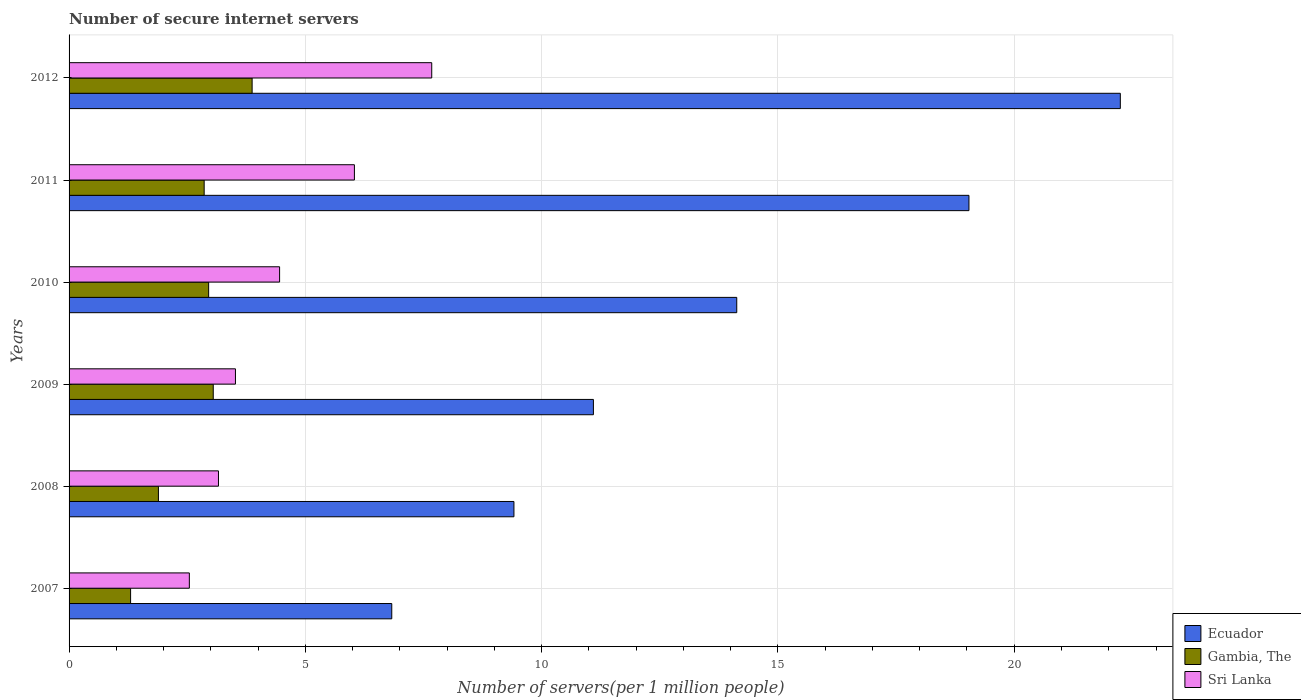How many groups of bars are there?
Your answer should be very brief. 6. Are the number of bars per tick equal to the number of legend labels?
Your answer should be compact. Yes. How many bars are there on the 2nd tick from the top?
Make the answer very short. 3. How many bars are there on the 4th tick from the bottom?
Your answer should be very brief. 3. What is the label of the 1st group of bars from the top?
Offer a very short reply. 2012. In how many cases, is the number of bars for a given year not equal to the number of legend labels?
Make the answer very short. 0. What is the number of secure internet servers in Ecuador in 2008?
Ensure brevity in your answer.  9.41. Across all years, what is the maximum number of secure internet servers in Ecuador?
Keep it short and to the point. 22.24. Across all years, what is the minimum number of secure internet servers in Ecuador?
Make the answer very short. 6.83. In which year was the number of secure internet servers in Ecuador minimum?
Provide a succinct answer. 2007. What is the total number of secure internet servers in Sri Lanka in the graph?
Offer a terse response. 27.39. What is the difference between the number of secure internet servers in Gambia, The in 2009 and that in 2011?
Offer a terse response. 0.19. What is the difference between the number of secure internet servers in Ecuador in 2010 and the number of secure internet servers in Sri Lanka in 2012?
Ensure brevity in your answer.  6.45. What is the average number of secure internet servers in Gambia, The per year?
Offer a terse response. 2.65. In the year 2011, what is the difference between the number of secure internet servers in Ecuador and number of secure internet servers in Gambia, The?
Your answer should be compact. 16.18. What is the ratio of the number of secure internet servers in Gambia, The in 2008 to that in 2011?
Provide a succinct answer. 0.66. Is the difference between the number of secure internet servers in Ecuador in 2007 and 2010 greater than the difference between the number of secure internet servers in Gambia, The in 2007 and 2010?
Your answer should be very brief. No. What is the difference between the highest and the second highest number of secure internet servers in Gambia, The?
Make the answer very short. 0.82. What is the difference between the highest and the lowest number of secure internet servers in Sri Lanka?
Keep it short and to the point. 5.13. In how many years, is the number of secure internet servers in Sri Lanka greater than the average number of secure internet servers in Sri Lanka taken over all years?
Ensure brevity in your answer.  2. Is the sum of the number of secure internet servers in Gambia, The in 2010 and 2012 greater than the maximum number of secure internet servers in Sri Lanka across all years?
Provide a short and direct response. No. What does the 3rd bar from the top in 2010 represents?
Offer a very short reply. Ecuador. What does the 2nd bar from the bottom in 2008 represents?
Provide a succinct answer. Gambia, The. Is it the case that in every year, the sum of the number of secure internet servers in Gambia, The and number of secure internet servers in Ecuador is greater than the number of secure internet servers in Sri Lanka?
Provide a succinct answer. Yes. Are the values on the major ticks of X-axis written in scientific E-notation?
Provide a short and direct response. No. Does the graph contain any zero values?
Keep it short and to the point. No. Does the graph contain grids?
Your answer should be compact. Yes. How are the legend labels stacked?
Provide a succinct answer. Vertical. What is the title of the graph?
Your response must be concise. Number of secure internet servers. Does "Benin" appear as one of the legend labels in the graph?
Keep it short and to the point. No. What is the label or title of the X-axis?
Give a very brief answer. Number of servers(per 1 million people). What is the Number of servers(per 1 million people) of Ecuador in 2007?
Keep it short and to the point. 6.83. What is the Number of servers(per 1 million people) of Gambia, The in 2007?
Offer a terse response. 1.3. What is the Number of servers(per 1 million people) in Sri Lanka in 2007?
Offer a terse response. 2.55. What is the Number of servers(per 1 million people) in Ecuador in 2008?
Provide a succinct answer. 9.41. What is the Number of servers(per 1 million people) in Gambia, The in 2008?
Offer a very short reply. 1.89. What is the Number of servers(per 1 million people) in Sri Lanka in 2008?
Keep it short and to the point. 3.16. What is the Number of servers(per 1 million people) of Ecuador in 2009?
Provide a succinct answer. 11.09. What is the Number of servers(per 1 million people) of Gambia, The in 2009?
Your answer should be compact. 3.05. What is the Number of servers(per 1 million people) of Sri Lanka in 2009?
Ensure brevity in your answer.  3.52. What is the Number of servers(per 1 million people) of Ecuador in 2010?
Make the answer very short. 14.13. What is the Number of servers(per 1 million people) of Gambia, The in 2010?
Provide a succinct answer. 2.95. What is the Number of servers(per 1 million people) of Sri Lanka in 2010?
Provide a succinct answer. 4.45. What is the Number of servers(per 1 million people) of Ecuador in 2011?
Your answer should be very brief. 19.04. What is the Number of servers(per 1 million people) in Gambia, The in 2011?
Keep it short and to the point. 2.86. What is the Number of servers(per 1 million people) of Sri Lanka in 2011?
Provide a short and direct response. 6.04. What is the Number of servers(per 1 million people) in Ecuador in 2012?
Offer a terse response. 22.24. What is the Number of servers(per 1 million people) in Gambia, The in 2012?
Your answer should be very brief. 3.87. What is the Number of servers(per 1 million people) in Sri Lanka in 2012?
Your response must be concise. 7.67. Across all years, what is the maximum Number of servers(per 1 million people) in Ecuador?
Make the answer very short. 22.24. Across all years, what is the maximum Number of servers(per 1 million people) of Gambia, The?
Make the answer very short. 3.87. Across all years, what is the maximum Number of servers(per 1 million people) in Sri Lanka?
Ensure brevity in your answer.  7.67. Across all years, what is the minimum Number of servers(per 1 million people) in Ecuador?
Your response must be concise. 6.83. Across all years, what is the minimum Number of servers(per 1 million people) of Gambia, The?
Offer a terse response. 1.3. Across all years, what is the minimum Number of servers(per 1 million people) of Sri Lanka?
Your answer should be very brief. 2.55. What is the total Number of servers(per 1 million people) of Ecuador in the graph?
Make the answer very short. 82.75. What is the total Number of servers(per 1 million people) of Gambia, The in the graph?
Provide a short and direct response. 15.93. What is the total Number of servers(per 1 million people) of Sri Lanka in the graph?
Offer a terse response. 27.39. What is the difference between the Number of servers(per 1 million people) of Ecuador in 2007 and that in 2008?
Offer a terse response. -2.58. What is the difference between the Number of servers(per 1 million people) in Gambia, The in 2007 and that in 2008?
Make the answer very short. -0.59. What is the difference between the Number of servers(per 1 million people) of Sri Lanka in 2007 and that in 2008?
Provide a short and direct response. -0.62. What is the difference between the Number of servers(per 1 million people) of Ecuador in 2007 and that in 2009?
Keep it short and to the point. -4.27. What is the difference between the Number of servers(per 1 million people) in Gambia, The in 2007 and that in 2009?
Provide a succinct answer. -1.75. What is the difference between the Number of servers(per 1 million people) in Sri Lanka in 2007 and that in 2009?
Give a very brief answer. -0.98. What is the difference between the Number of servers(per 1 million people) of Ecuador in 2007 and that in 2010?
Offer a very short reply. -7.3. What is the difference between the Number of servers(per 1 million people) in Gambia, The in 2007 and that in 2010?
Provide a short and direct response. -1.65. What is the difference between the Number of servers(per 1 million people) of Sri Lanka in 2007 and that in 2010?
Offer a terse response. -1.91. What is the difference between the Number of servers(per 1 million people) of Ecuador in 2007 and that in 2011?
Make the answer very short. -12.21. What is the difference between the Number of servers(per 1 million people) in Gambia, The in 2007 and that in 2011?
Ensure brevity in your answer.  -1.56. What is the difference between the Number of servers(per 1 million people) of Sri Lanka in 2007 and that in 2011?
Your answer should be compact. -3.49. What is the difference between the Number of servers(per 1 million people) of Ecuador in 2007 and that in 2012?
Offer a terse response. -15.42. What is the difference between the Number of servers(per 1 million people) of Gambia, The in 2007 and that in 2012?
Offer a very short reply. -2.57. What is the difference between the Number of servers(per 1 million people) in Sri Lanka in 2007 and that in 2012?
Ensure brevity in your answer.  -5.13. What is the difference between the Number of servers(per 1 million people) of Ecuador in 2008 and that in 2009?
Offer a terse response. -1.68. What is the difference between the Number of servers(per 1 million people) of Gambia, The in 2008 and that in 2009?
Make the answer very short. -1.16. What is the difference between the Number of servers(per 1 million people) in Sri Lanka in 2008 and that in 2009?
Offer a very short reply. -0.36. What is the difference between the Number of servers(per 1 million people) in Ecuador in 2008 and that in 2010?
Keep it short and to the point. -4.71. What is the difference between the Number of servers(per 1 million people) of Gambia, The in 2008 and that in 2010?
Offer a very short reply. -1.06. What is the difference between the Number of servers(per 1 million people) in Sri Lanka in 2008 and that in 2010?
Your answer should be very brief. -1.29. What is the difference between the Number of servers(per 1 million people) of Ecuador in 2008 and that in 2011?
Your answer should be compact. -9.63. What is the difference between the Number of servers(per 1 million people) of Gambia, The in 2008 and that in 2011?
Make the answer very short. -0.97. What is the difference between the Number of servers(per 1 million people) in Sri Lanka in 2008 and that in 2011?
Your answer should be compact. -2.88. What is the difference between the Number of servers(per 1 million people) of Ecuador in 2008 and that in 2012?
Offer a very short reply. -12.83. What is the difference between the Number of servers(per 1 million people) in Gambia, The in 2008 and that in 2012?
Keep it short and to the point. -1.98. What is the difference between the Number of servers(per 1 million people) of Sri Lanka in 2008 and that in 2012?
Provide a succinct answer. -4.51. What is the difference between the Number of servers(per 1 million people) in Ecuador in 2009 and that in 2010?
Your response must be concise. -3.03. What is the difference between the Number of servers(per 1 million people) in Gambia, The in 2009 and that in 2010?
Your answer should be very brief. 0.1. What is the difference between the Number of servers(per 1 million people) in Sri Lanka in 2009 and that in 2010?
Give a very brief answer. -0.93. What is the difference between the Number of servers(per 1 million people) of Ecuador in 2009 and that in 2011?
Offer a terse response. -7.95. What is the difference between the Number of servers(per 1 million people) in Gambia, The in 2009 and that in 2011?
Your response must be concise. 0.19. What is the difference between the Number of servers(per 1 million people) of Sri Lanka in 2009 and that in 2011?
Provide a succinct answer. -2.52. What is the difference between the Number of servers(per 1 million people) in Ecuador in 2009 and that in 2012?
Provide a short and direct response. -11.15. What is the difference between the Number of servers(per 1 million people) in Gambia, The in 2009 and that in 2012?
Ensure brevity in your answer.  -0.82. What is the difference between the Number of servers(per 1 million people) in Sri Lanka in 2009 and that in 2012?
Make the answer very short. -4.15. What is the difference between the Number of servers(per 1 million people) of Ecuador in 2010 and that in 2011?
Keep it short and to the point. -4.91. What is the difference between the Number of servers(per 1 million people) in Gambia, The in 2010 and that in 2011?
Your answer should be compact. 0.09. What is the difference between the Number of servers(per 1 million people) in Sri Lanka in 2010 and that in 2011?
Make the answer very short. -1.58. What is the difference between the Number of servers(per 1 million people) of Ecuador in 2010 and that in 2012?
Your response must be concise. -8.12. What is the difference between the Number of servers(per 1 million people) of Gambia, The in 2010 and that in 2012?
Offer a very short reply. -0.92. What is the difference between the Number of servers(per 1 million people) in Sri Lanka in 2010 and that in 2012?
Ensure brevity in your answer.  -3.22. What is the difference between the Number of servers(per 1 million people) in Ecuador in 2011 and that in 2012?
Offer a terse response. -3.2. What is the difference between the Number of servers(per 1 million people) of Gambia, The in 2011 and that in 2012?
Ensure brevity in your answer.  -1.01. What is the difference between the Number of servers(per 1 million people) in Sri Lanka in 2011 and that in 2012?
Your response must be concise. -1.64. What is the difference between the Number of servers(per 1 million people) in Ecuador in 2007 and the Number of servers(per 1 million people) in Gambia, The in 2008?
Your answer should be very brief. 4.94. What is the difference between the Number of servers(per 1 million people) in Ecuador in 2007 and the Number of servers(per 1 million people) in Sri Lanka in 2008?
Your answer should be compact. 3.67. What is the difference between the Number of servers(per 1 million people) of Gambia, The in 2007 and the Number of servers(per 1 million people) of Sri Lanka in 2008?
Keep it short and to the point. -1.86. What is the difference between the Number of servers(per 1 million people) in Ecuador in 2007 and the Number of servers(per 1 million people) in Gambia, The in 2009?
Ensure brevity in your answer.  3.78. What is the difference between the Number of servers(per 1 million people) in Ecuador in 2007 and the Number of servers(per 1 million people) in Sri Lanka in 2009?
Ensure brevity in your answer.  3.31. What is the difference between the Number of servers(per 1 million people) of Gambia, The in 2007 and the Number of servers(per 1 million people) of Sri Lanka in 2009?
Your response must be concise. -2.22. What is the difference between the Number of servers(per 1 million people) in Ecuador in 2007 and the Number of servers(per 1 million people) in Gambia, The in 2010?
Your answer should be compact. 3.88. What is the difference between the Number of servers(per 1 million people) of Ecuador in 2007 and the Number of servers(per 1 million people) of Sri Lanka in 2010?
Offer a terse response. 2.37. What is the difference between the Number of servers(per 1 million people) in Gambia, The in 2007 and the Number of servers(per 1 million people) in Sri Lanka in 2010?
Keep it short and to the point. -3.15. What is the difference between the Number of servers(per 1 million people) of Ecuador in 2007 and the Number of servers(per 1 million people) of Gambia, The in 2011?
Ensure brevity in your answer.  3.97. What is the difference between the Number of servers(per 1 million people) in Ecuador in 2007 and the Number of servers(per 1 million people) in Sri Lanka in 2011?
Give a very brief answer. 0.79. What is the difference between the Number of servers(per 1 million people) in Gambia, The in 2007 and the Number of servers(per 1 million people) in Sri Lanka in 2011?
Keep it short and to the point. -4.74. What is the difference between the Number of servers(per 1 million people) in Ecuador in 2007 and the Number of servers(per 1 million people) in Gambia, The in 2012?
Make the answer very short. 2.95. What is the difference between the Number of servers(per 1 million people) of Ecuador in 2007 and the Number of servers(per 1 million people) of Sri Lanka in 2012?
Make the answer very short. -0.85. What is the difference between the Number of servers(per 1 million people) in Gambia, The in 2007 and the Number of servers(per 1 million people) in Sri Lanka in 2012?
Provide a short and direct response. -6.37. What is the difference between the Number of servers(per 1 million people) in Ecuador in 2008 and the Number of servers(per 1 million people) in Gambia, The in 2009?
Your response must be concise. 6.36. What is the difference between the Number of servers(per 1 million people) in Ecuador in 2008 and the Number of servers(per 1 million people) in Sri Lanka in 2009?
Ensure brevity in your answer.  5.89. What is the difference between the Number of servers(per 1 million people) in Gambia, The in 2008 and the Number of servers(per 1 million people) in Sri Lanka in 2009?
Your response must be concise. -1.63. What is the difference between the Number of servers(per 1 million people) in Ecuador in 2008 and the Number of servers(per 1 million people) in Gambia, The in 2010?
Your answer should be very brief. 6.46. What is the difference between the Number of servers(per 1 million people) in Ecuador in 2008 and the Number of servers(per 1 million people) in Sri Lanka in 2010?
Your answer should be compact. 4.96. What is the difference between the Number of servers(per 1 million people) in Gambia, The in 2008 and the Number of servers(per 1 million people) in Sri Lanka in 2010?
Ensure brevity in your answer.  -2.56. What is the difference between the Number of servers(per 1 million people) of Ecuador in 2008 and the Number of servers(per 1 million people) of Gambia, The in 2011?
Provide a short and direct response. 6.55. What is the difference between the Number of servers(per 1 million people) in Ecuador in 2008 and the Number of servers(per 1 million people) in Sri Lanka in 2011?
Provide a succinct answer. 3.38. What is the difference between the Number of servers(per 1 million people) in Gambia, The in 2008 and the Number of servers(per 1 million people) in Sri Lanka in 2011?
Your answer should be compact. -4.15. What is the difference between the Number of servers(per 1 million people) of Ecuador in 2008 and the Number of servers(per 1 million people) of Gambia, The in 2012?
Offer a terse response. 5.54. What is the difference between the Number of servers(per 1 million people) of Ecuador in 2008 and the Number of servers(per 1 million people) of Sri Lanka in 2012?
Give a very brief answer. 1.74. What is the difference between the Number of servers(per 1 million people) in Gambia, The in 2008 and the Number of servers(per 1 million people) in Sri Lanka in 2012?
Keep it short and to the point. -5.78. What is the difference between the Number of servers(per 1 million people) in Ecuador in 2009 and the Number of servers(per 1 million people) in Gambia, The in 2010?
Your response must be concise. 8.14. What is the difference between the Number of servers(per 1 million people) in Ecuador in 2009 and the Number of servers(per 1 million people) in Sri Lanka in 2010?
Give a very brief answer. 6.64. What is the difference between the Number of servers(per 1 million people) of Gambia, The in 2009 and the Number of servers(per 1 million people) of Sri Lanka in 2010?
Give a very brief answer. -1.4. What is the difference between the Number of servers(per 1 million people) of Ecuador in 2009 and the Number of servers(per 1 million people) of Gambia, The in 2011?
Make the answer very short. 8.24. What is the difference between the Number of servers(per 1 million people) of Ecuador in 2009 and the Number of servers(per 1 million people) of Sri Lanka in 2011?
Offer a very short reply. 5.06. What is the difference between the Number of servers(per 1 million people) in Gambia, The in 2009 and the Number of servers(per 1 million people) in Sri Lanka in 2011?
Offer a terse response. -2.99. What is the difference between the Number of servers(per 1 million people) of Ecuador in 2009 and the Number of servers(per 1 million people) of Gambia, The in 2012?
Make the answer very short. 7.22. What is the difference between the Number of servers(per 1 million people) in Ecuador in 2009 and the Number of servers(per 1 million people) in Sri Lanka in 2012?
Give a very brief answer. 3.42. What is the difference between the Number of servers(per 1 million people) of Gambia, The in 2009 and the Number of servers(per 1 million people) of Sri Lanka in 2012?
Your answer should be very brief. -4.62. What is the difference between the Number of servers(per 1 million people) in Ecuador in 2010 and the Number of servers(per 1 million people) in Gambia, The in 2011?
Keep it short and to the point. 11.27. What is the difference between the Number of servers(per 1 million people) in Ecuador in 2010 and the Number of servers(per 1 million people) in Sri Lanka in 2011?
Give a very brief answer. 8.09. What is the difference between the Number of servers(per 1 million people) of Gambia, The in 2010 and the Number of servers(per 1 million people) of Sri Lanka in 2011?
Provide a short and direct response. -3.08. What is the difference between the Number of servers(per 1 million people) in Ecuador in 2010 and the Number of servers(per 1 million people) in Gambia, The in 2012?
Keep it short and to the point. 10.25. What is the difference between the Number of servers(per 1 million people) of Ecuador in 2010 and the Number of servers(per 1 million people) of Sri Lanka in 2012?
Your response must be concise. 6.45. What is the difference between the Number of servers(per 1 million people) in Gambia, The in 2010 and the Number of servers(per 1 million people) in Sri Lanka in 2012?
Ensure brevity in your answer.  -4.72. What is the difference between the Number of servers(per 1 million people) in Ecuador in 2011 and the Number of servers(per 1 million people) in Gambia, The in 2012?
Give a very brief answer. 15.17. What is the difference between the Number of servers(per 1 million people) in Ecuador in 2011 and the Number of servers(per 1 million people) in Sri Lanka in 2012?
Offer a terse response. 11.37. What is the difference between the Number of servers(per 1 million people) in Gambia, The in 2011 and the Number of servers(per 1 million people) in Sri Lanka in 2012?
Your response must be concise. -4.82. What is the average Number of servers(per 1 million people) of Ecuador per year?
Give a very brief answer. 13.79. What is the average Number of servers(per 1 million people) of Gambia, The per year?
Your response must be concise. 2.65. What is the average Number of servers(per 1 million people) of Sri Lanka per year?
Offer a terse response. 4.57. In the year 2007, what is the difference between the Number of servers(per 1 million people) in Ecuador and Number of servers(per 1 million people) in Gambia, The?
Offer a terse response. 5.53. In the year 2007, what is the difference between the Number of servers(per 1 million people) in Ecuador and Number of servers(per 1 million people) in Sri Lanka?
Your response must be concise. 4.28. In the year 2007, what is the difference between the Number of servers(per 1 million people) in Gambia, The and Number of servers(per 1 million people) in Sri Lanka?
Provide a succinct answer. -1.24. In the year 2008, what is the difference between the Number of servers(per 1 million people) of Ecuador and Number of servers(per 1 million people) of Gambia, The?
Ensure brevity in your answer.  7.52. In the year 2008, what is the difference between the Number of servers(per 1 million people) of Ecuador and Number of servers(per 1 million people) of Sri Lanka?
Make the answer very short. 6.25. In the year 2008, what is the difference between the Number of servers(per 1 million people) in Gambia, The and Number of servers(per 1 million people) in Sri Lanka?
Provide a short and direct response. -1.27. In the year 2009, what is the difference between the Number of servers(per 1 million people) of Ecuador and Number of servers(per 1 million people) of Gambia, The?
Your answer should be compact. 8.04. In the year 2009, what is the difference between the Number of servers(per 1 million people) in Ecuador and Number of servers(per 1 million people) in Sri Lanka?
Your response must be concise. 7.57. In the year 2009, what is the difference between the Number of servers(per 1 million people) in Gambia, The and Number of servers(per 1 million people) in Sri Lanka?
Provide a short and direct response. -0.47. In the year 2010, what is the difference between the Number of servers(per 1 million people) of Ecuador and Number of servers(per 1 million people) of Gambia, The?
Offer a terse response. 11.17. In the year 2010, what is the difference between the Number of servers(per 1 million people) of Ecuador and Number of servers(per 1 million people) of Sri Lanka?
Offer a very short reply. 9.67. In the year 2010, what is the difference between the Number of servers(per 1 million people) of Gambia, The and Number of servers(per 1 million people) of Sri Lanka?
Provide a succinct answer. -1.5. In the year 2011, what is the difference between the Number of servers(per 1 million people) of Ecuador and Number of servers(per 1 million people) of Gambia, The?
Your answer should be very brief. 16.18. In the year 2011, what is the difference between the Number of servers(per 1 million people) in Ecuador and Number of servers(per 1 million people) in Sri Lanka?
Provide a short and direct response. 13. In the year 2011, what is the difference between the Number of servers(per 1 million people) of Gambia, The and Number of servers(per 1 million people) of Sri Lanka?
Offer a very short reply. -3.18. In the year 2012, what is the difference between the Number of servers(per 1 million people) in Ecuador and Number of servers(per 1 million people) in Gambia, The?
Your response must be concise. 18.37. In the year 2012, what is the difference between the Number of servers(per 1 million people) of Ecuador and Number of servers(per 1 million people) of Sri Lanka?
Provide a short and direct response. 14.57. In the year 2012, what is the difference between the Number of servers(per 1 million people) in Gambia, The and Number of servers(per 1 million people) in Sri Lanka?
Your response must be concise. -3.8. What is the ratio of the Number of servers(per 1 million people) in Ecuador in 2007 to that in 2008?
Provide a succinct answer. 0.73. What is the ratio of the Number of servers(per 1 million people) in Gambia, The in 2007 to that in 2008?
Offer a terse response. 0.69. What is the ratio of the Number of servers(per 1 million people) in Sri Lanka in 2007 to that in 2008?
Your answer should be very brief. 0.81. What is the ratio of the Number of servers(per 1 million people) of Ecuador in 2007 to that in 2009?
Keep it short and to the point. 0.62. What is the ratio of the Number of servers(per 1 million people) in Gambia, The in 2007 to that in 2009?
Make the answer very short. 0.43. What is the ratio of the Number of servers(per 1 million people) of Sri Lanka in 2007 to that in 2009?
Provide a short and direct response. 0.72. What is the ratio of the Number of servers(per 1 million people) of Ecuador in 2007 to that in 2010?
Your answer should be very brief. 0.48. What is the ratio of the Number of servers(per 1 million people) of Gambia, The in 2007 to that in 2010?
Provide a succinct answer. 0.44. What is the ratio of the Number of servers(per 1 million people) in Sri Lanka in 2007 to that in 2010?
Your response must be concise. 0.57. What is the ratio of the Number of servers(per 1 million people) in Ecuador in 2007 to that in 2011?
Your response must be concise. 0.36. What is the ratio of the Number of servers(per 1 million people) of Gambia, The in 2007 to that in 2011?
Keep it short and to the point. 0.46. What is the ratio of the Number of servers(per 1 million people) in Sri Lanka in 2007 to that in 2011?
Your response must be concise. 0.42. What is the ratio of the Number of servers(per 1 million people) of Ecuador in 2007 to that in 2012?
Ensure brevity in your answer.  0.31. What is the ratio of the Number of servers(per 1 million people) of Gambia, The in 2007 to that in 2012?
Your answer should be compact. 0.34. What is the ratio of the Number of servers(per 1 million people) in Sri Lanka in 2007 to that in 2012?
Give a very brief answer. 0.33. What is the ratio of the Number of servers(per 1 million people) of Ecuador in 2008 to that in 2009?
Provide a succinct answer. 0.85. What is the ratio of the Number of servers(per 1 million people) in Gambia, The in 2008 to that in 2009?
Your response must be concise. 0.62. What is the ratio of the Number of servers(per 1 million people) of Sri Lanka in 2008 to that in 2009?
Offer a terse response. 0.9. What is the ratio of the Number of servers(per 1 million people) of Ecuador in 2008 to that in 2010?
Your answer should be compact. 0.67. What is the ratio of the Number of servers(per 1 million people) of Gambia, The in 2008 to that in 2010?
Keep it short and to the point. 0.64. What is the ratio of the Number of servers(per 1 million people) of Sri Lanka in 2008 to that in 2010?
Your answer should be compact. 0.71. What is the ratio of the Number of servers(per 1 million people) in Ecuador in 2008 to that in 2011?
Your answer should be compact. 0.49. What is the ratio of the Number of servers(per 1 million people) in Gambia, The in 2008 to that in 2011?
Your answer should be compact. 0.66. What is the ratio of the Number of servers(per 1 million people) of Sri Lanka in 2008 to that in 2011?
Ensure brevity in your answer.  0.52. What is the ratio of the Number of servers(per 1 million people) in Ecuador in 2008 to that in 2012?
Ensure brevity in your answer.  0.42. What is the ratio of the Number of servers(per 1 million people) of Gambia, The in 2008 to that in 2012?
Give a very brief answer. 0.49. What is the ratio of the Number of servers(per 1 million people) in Sri Lanka in 2008 to that in 2012?
Provide a succinct answer. 0.41. What is the ratio of the Number of servers(per 1 million people) of Ecuador in 2009 to that in 2010?
Offer a very short reply. 0.79. What is the ratio of the Number of servers(per 1 million people) in Gambia, The in 2009 to that in 2010?
Provide a succinct answer. 1.03. What is the ratio of the Number of servers(per 1 million people) in Sri Lanka in 2009 to that in 2010?
Provide a succinct answer. 0.79. What is the ratio of the Number of servers(per 1 million people) of Ecuador in 2009 to that in 2011?
Your answer should be very brief. 0.58. What is the ratio of the Number of servers(per 1 million people) in Gambia, The in 2009 to that in 2011?
Make the answer very short. 1.07. What is the ratio of the Number of servers(per 1 million people) of Sri Lanka in 2009 to that in 2011?
Provide a short and direct response. 0.58. What is the ratio of the Number of servers(per 1 million people) of Ecuador in 2009 to that in 2012?
Offer a terse response. 0.5. What is the ratio of the Number of servers(per 1 million people) in Gambia, The in 2009 to that in 2012?
Provide a short and direct response. 0.79. What is the ratio of the Number of servers(per 1 million people) in Sri Lanka in 2009 to that in 2012?
Your answer should be compact. 0.46. What is the ratio of the Number of servers(per 1 million people) of Ecuador in 2010 to that in 2011?
Provide a short and direct response. 0.74. What is the ratio of the Number of servers(per 1 million people) of Gambia, The in 2010 to that in 2011?
Provide a succinct answer. 1.03. What is the ratio of the Number of servers(per 1 million people) of Sri Lanka in 2010 to that in 2011?
Offer a terse response. 0.74. What is the ratio of the Number of servers(per 1 million people) in Ecuador in 2010 to that in 2012?
Offer a very short reply. 0.64. What is the ratio of the Number of servers(per 1 million people) of Gambia, The in 2010 to that in 2012?
Provide a succinct answer. 0.76. What is the ratio of the Number of servers(per 1 million people) of Sri Lanka in 2010 to that in 2012?
Offer a terse response. 0.58. What is the ratio of the Number of servers(per 1 million people) of Ecuador in 2011 to that in 2012?
Your response must be concise. 0.86. What is the ratio of the Number of servers(per 1 million people) in Gambia, The in 2011 to that in 2012?
Offer a very short reply. 0.74. What is the ratio of the Number of servers(per 1 million people) of Sri Lanka in 2011 to that in 2012?
Provide a succinct answer. 0.79. What is the difference between the highest and the second highest Number of servers(per 1 million people) in Ecuador?
Ensure brevity in your answer.  3.2. What is the difference between the highest and the second highest Number of servers(per 1 million people) in Gambia, The?
Offer a terse response. 0.82. What is the difference between the highest and the second highest Number of servers(per 1 million people) of Sri Lanka?
Offer a very short reply. 1.64. What is the difference between the highest and the lowest Number of servers(per 1 million people) in Ecuador?
Make the answer very short. 15.42. What is the difference between the highest and the lowest Number of servers(per 1 million people) of Gambia, The?
Your answer should be very brief. 2.57. What is the difference between the highest and the lowest Number of servers(per 1 million people) in Sri Lanka?
Offer a very short reply. 5.13. 